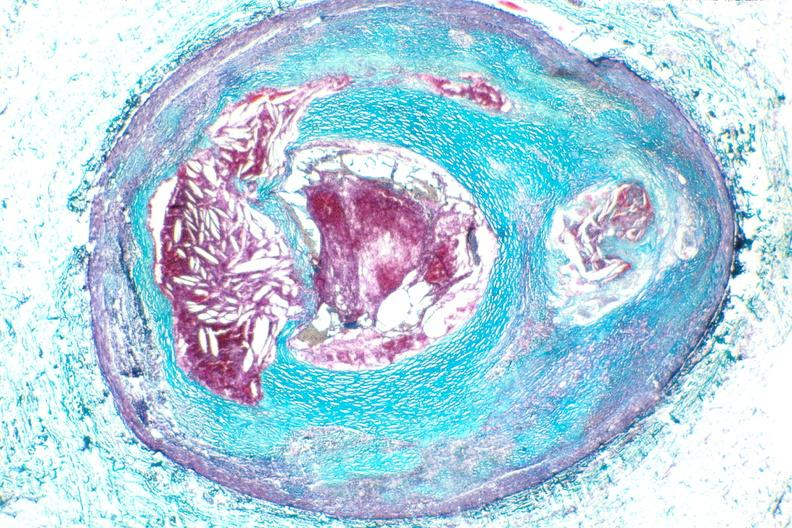where is this from?
Answer the question using a single word or phrase. Vasculature 